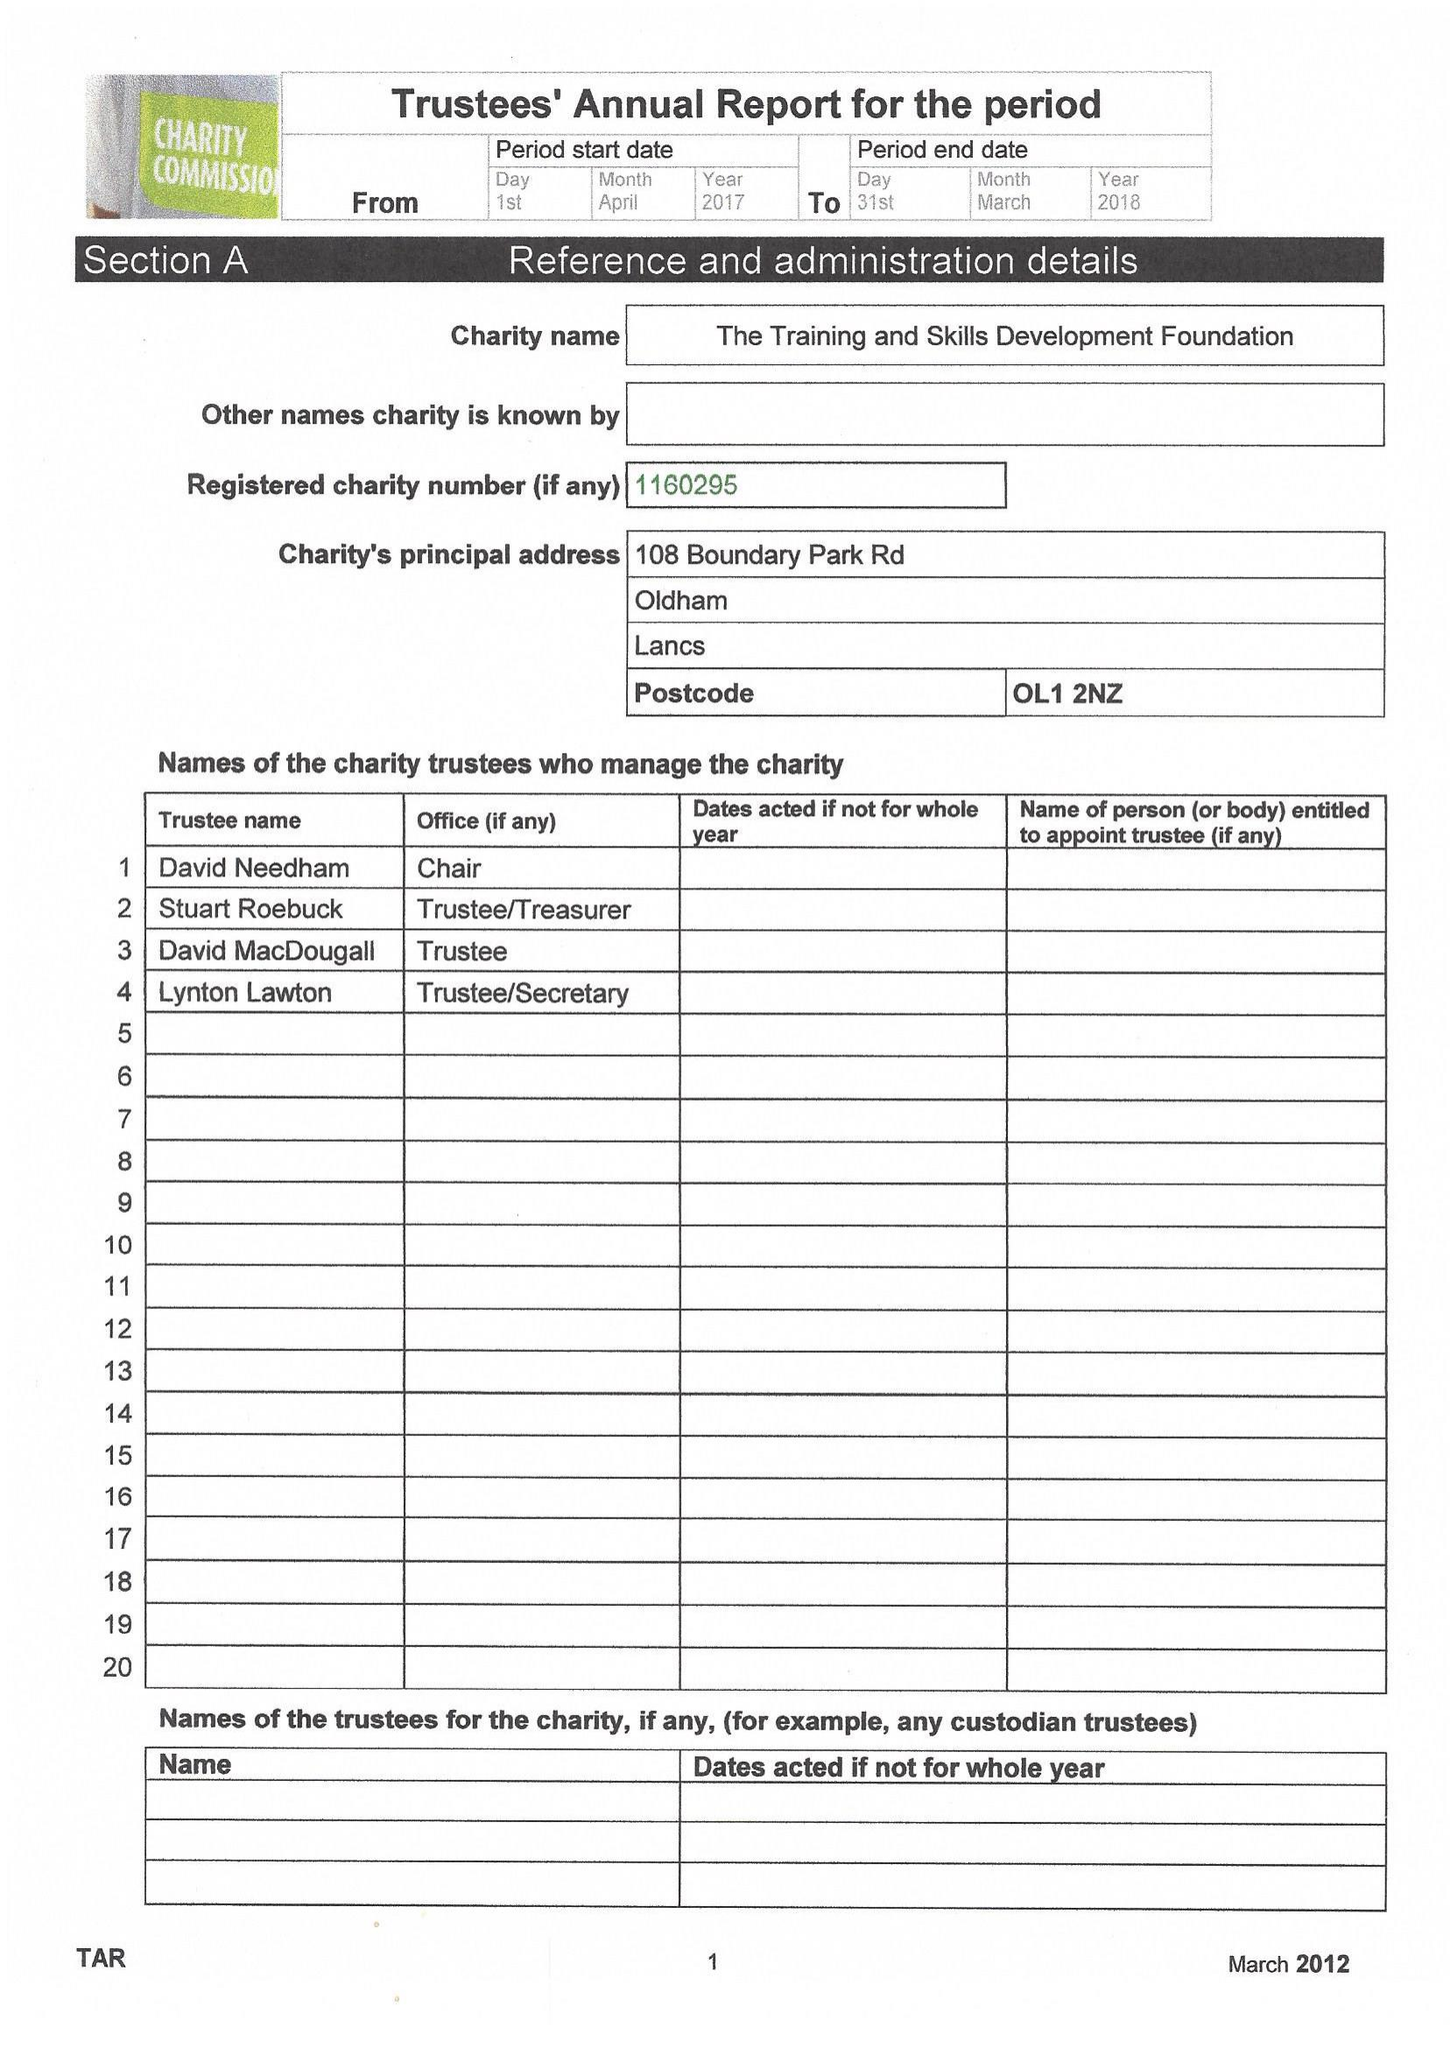What is the value for the charity_number?
Answer the question using a single word or phrase. 1160295 